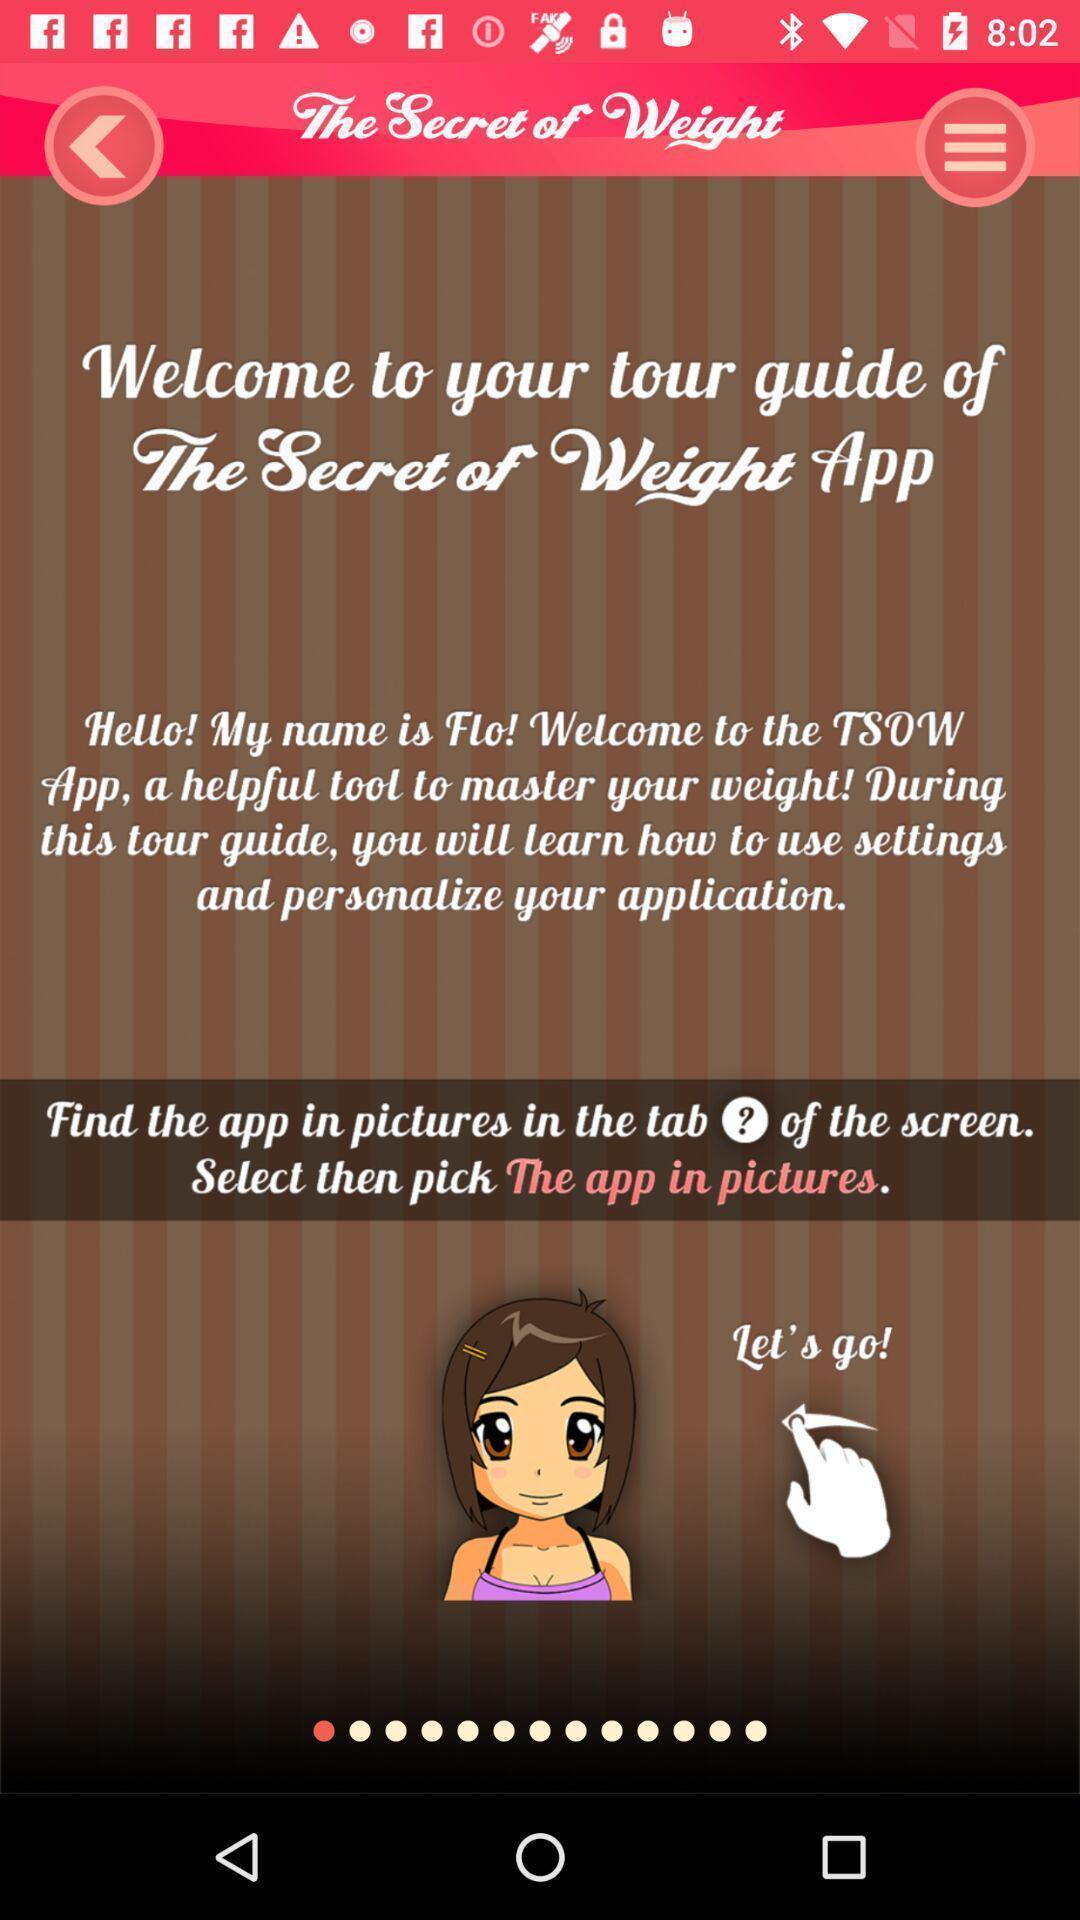Describe this image in words. Welcome page of a fitness app. 